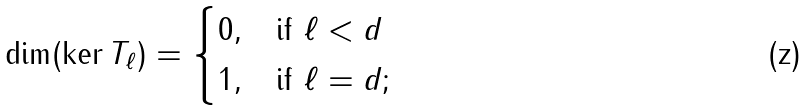<formula> <loc_0><loc_0><loc_500><loc_500>\dim ( \ker T _ { \ell } ) = \begin{cases} 0 , & \text {if $\ell < d$} \\ 1 , & \text {if $\ell = d$} ; \end{cases}</formula> 